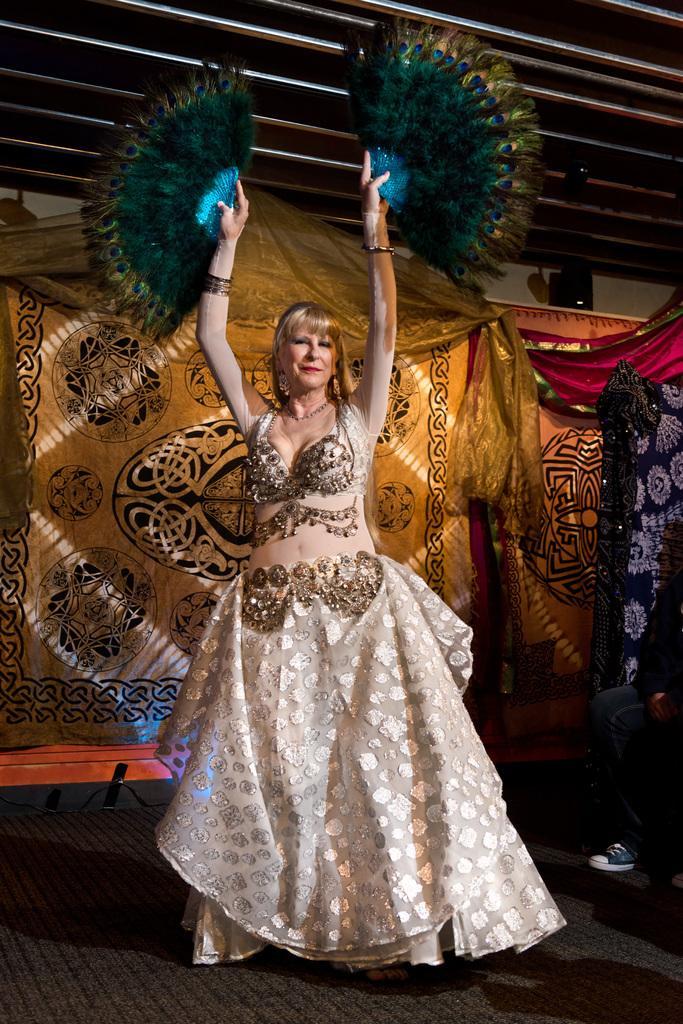Describe this image in one or two sentences. In the image there is a woman in gown and feather fans in her hands doing belly dance on the floor and behind her there are curtains. 